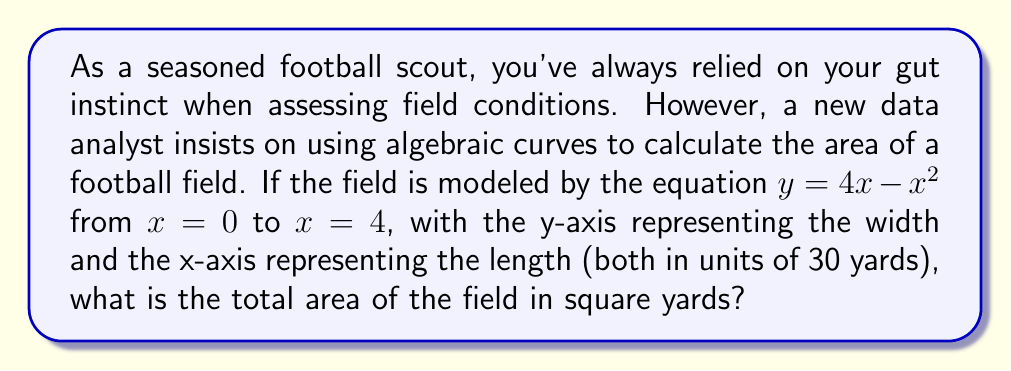Provide a solution to this math problem. Let's approach this step-by-step:

1) The field is represented by the curve $y = 4x - x^2$ from $x = 0$ to $x = 4$.

2) To find the area under this curve, we need to integrate:

   $$A = \int_{0}^{4} (4x - x^2) dx$$

3) Let's solve this integral:
   
   $$A = \left[2x^2 - \frac{1}{3}x^3\right]_{0}^{4}$$

4) Evaluating at the limits:
   
   $$A = \left(2(4)^2 - \frac{1}{3}(4)^3\right) - \left(2(0)^2 - \frac{1}{3}(0)^3\right)$$

5) Simplify:
   
   $$A = \left(32 - \frac{64}{3}\right) - 0 = 32 - \frac{64}{3} = \frac{32}{3}$$

6) This result is in units of 30 yards by 30 yards. To convert to square yards:

   $$A_{yards} = \frac{32}{3} * (30 * 30) = 9600 \text{ square yards}$$

Thus, the total area of the field is 9600 square yards.
Answer: 9600 square yards 